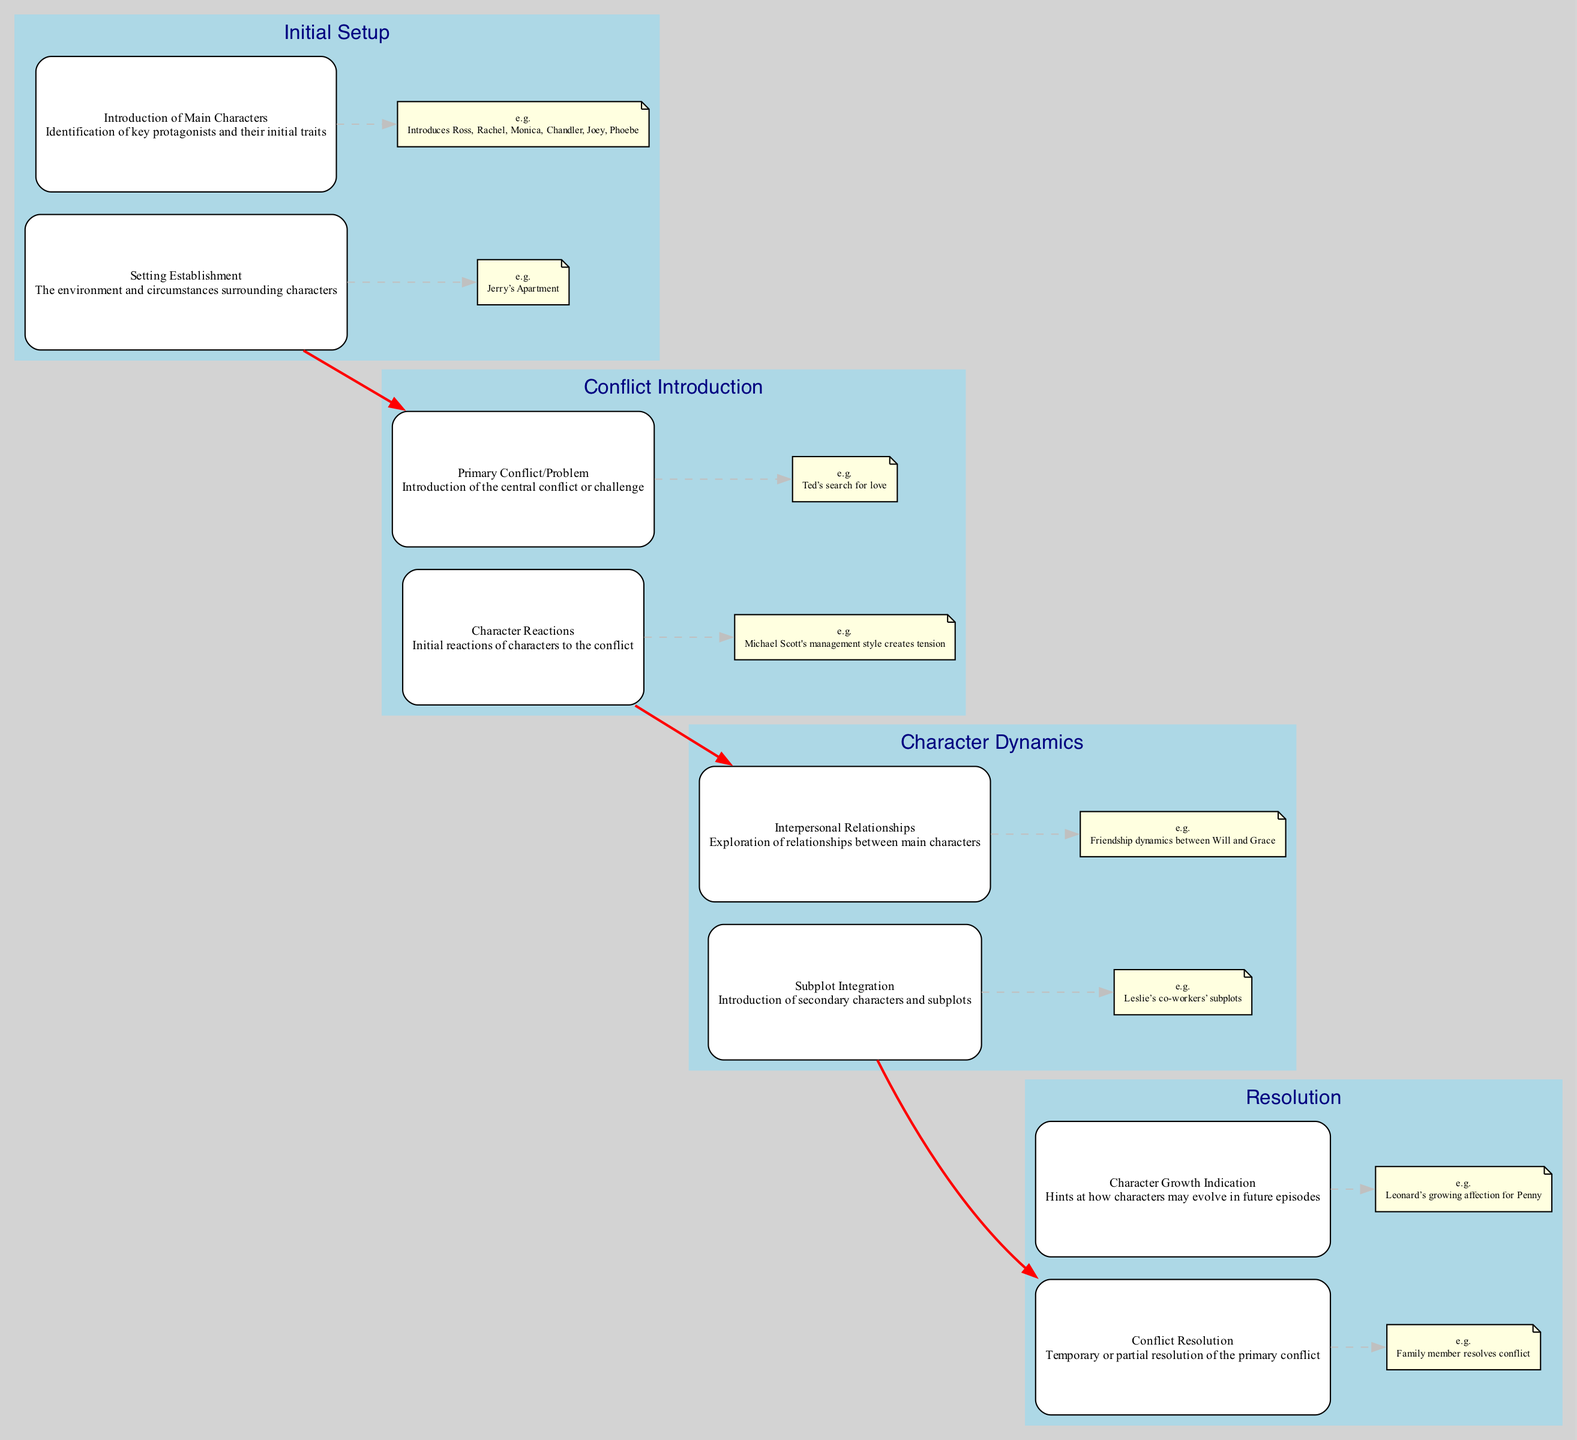What is the first stage in the diagram? The first stage in the diagram is labeled "Initial Setup". It is the starting point of the clinical pathway.
Answer: Initial Setup How many main characters are introduced in the "Initial Setup" stage? In the "Initial Setup" stage, two elements are identified. The first element "Introduction of Main Characters," which mentions main characters, indicates a focus on the initial traits of these characters.
Answer: 2 What is the primary conflict introduced in the sitcom "How I Met Your Mother"? The "Primary Conflict/Problem" element specifies that in "How I Met Your Mother," the primary conflict is Ted’s search for love.
Answer: Ted’s search for love Which stage focuses on character relationships? The stage titled "Character Dynamics" emphasizes the exploration of relationships between main characters, detailing interpersonal connections.
Answer: Character Dynamics What character reaction is indicated in "The Office"? The diagram describes "Character Reactions" in "The Office," where Michael Scott's management style creates tension among the staff.
Answer: Michael Scott's management style creates tension How does "Modern Family" resolve its conflict? The "Conflict Resolution" element illustrates that in "Modern Family," a family member resolves the conflict temporarily, which contributes to the storyline's progression.
Answer: Family member resolves conflict What does the "Character Growth Indication" stage hint at? This stage hints at possible character development in future episodes, particularly noting Leonard’s growing affection for Penny in "The Big Bang Theory".
Answer: Leonard’s growing affection for Penny What type of subplot integration is present in "Fais pas ci, fais pas ça"? The element "Subplot Integration" indicates that "Fais pas ci, fais pas ça" includes family subplots, showcasing additional narratives intertwined with the main plot.
Answer: Family subplots Which two stages are connected with a red edge? A red edge indicates a connection between the "Resolution" stage and the "Character Dynamics" stage, showing a flow from resolving conflicts back to the exploration of relationships.
Answer: Resolution and Character Dynamics 